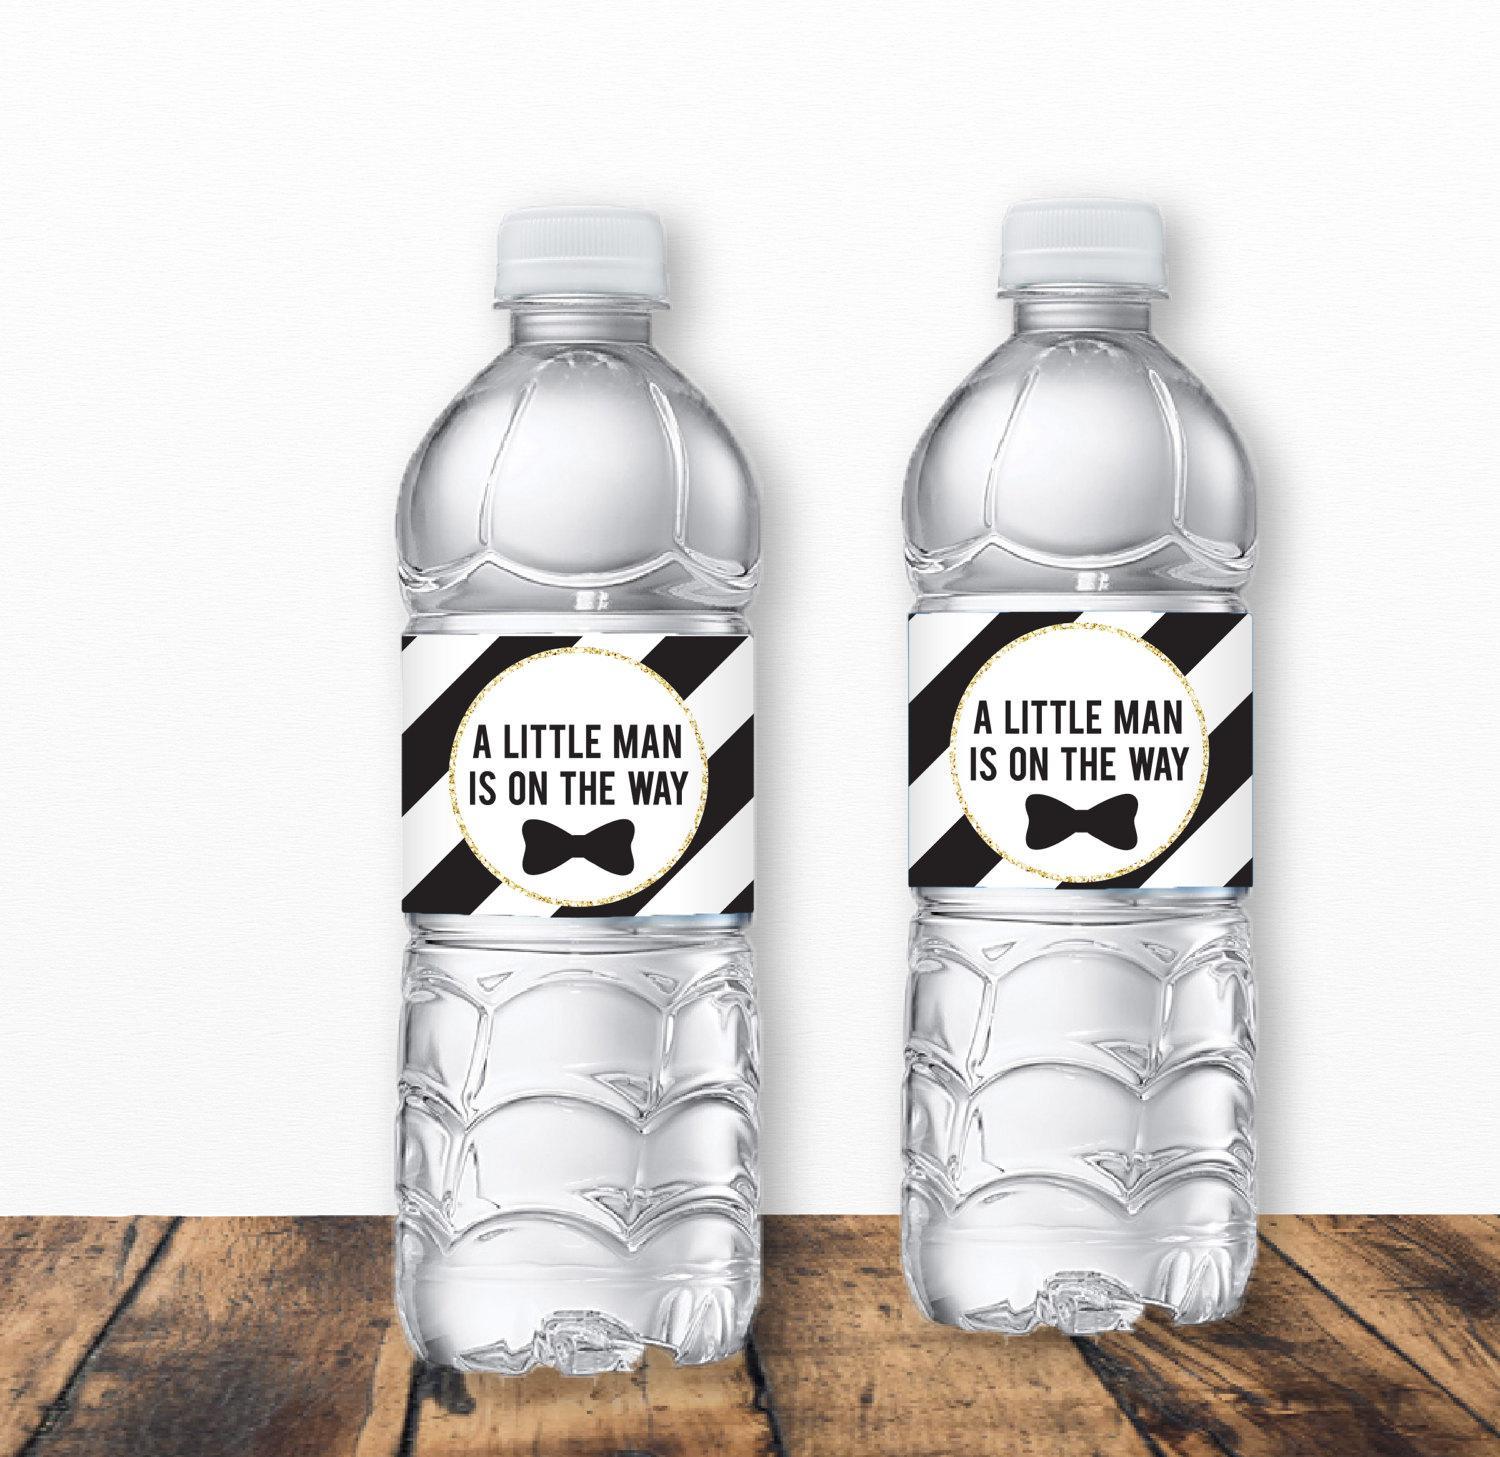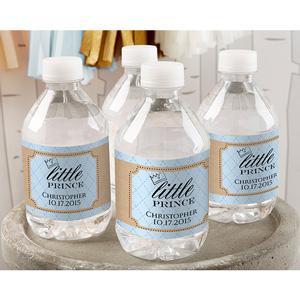The first image is the image on the left, the second image is the image on the right. Evaluate the accuracy of this statement regarding the images: "In at least one image there are two water bottles with a label that reference a new baby.". Is it true? Answer yes or no. Yes. The first image is the image on the left, the second image is the image on the right. Considering the images on both sides, is "There are no more than six water bottles in total." valid? Answer yes or no. Yes. 